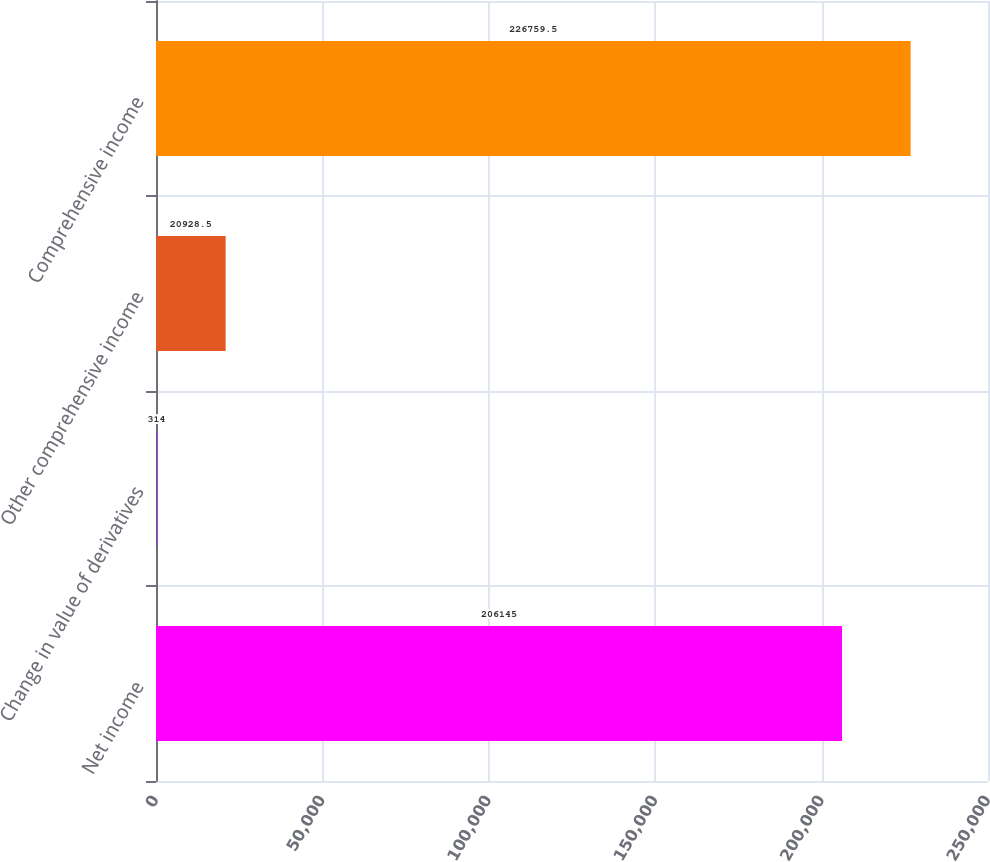<chart> <loc_0><loc_0><loc_500><loc_500><bar_chart><fcel>Net income<fcel>Change in value of derivatives<fcel>Other comprehensive income<fcel>Comprehensive income<nl><fcel>206145<fcel>314<fcel>20928.5<fcel>226760<nl></chart> 